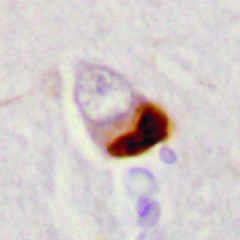re chronic inflammatory cells seen in association with loss of normal nuclear immunoreactivity?
Answer the question using a single word or phrase. No 